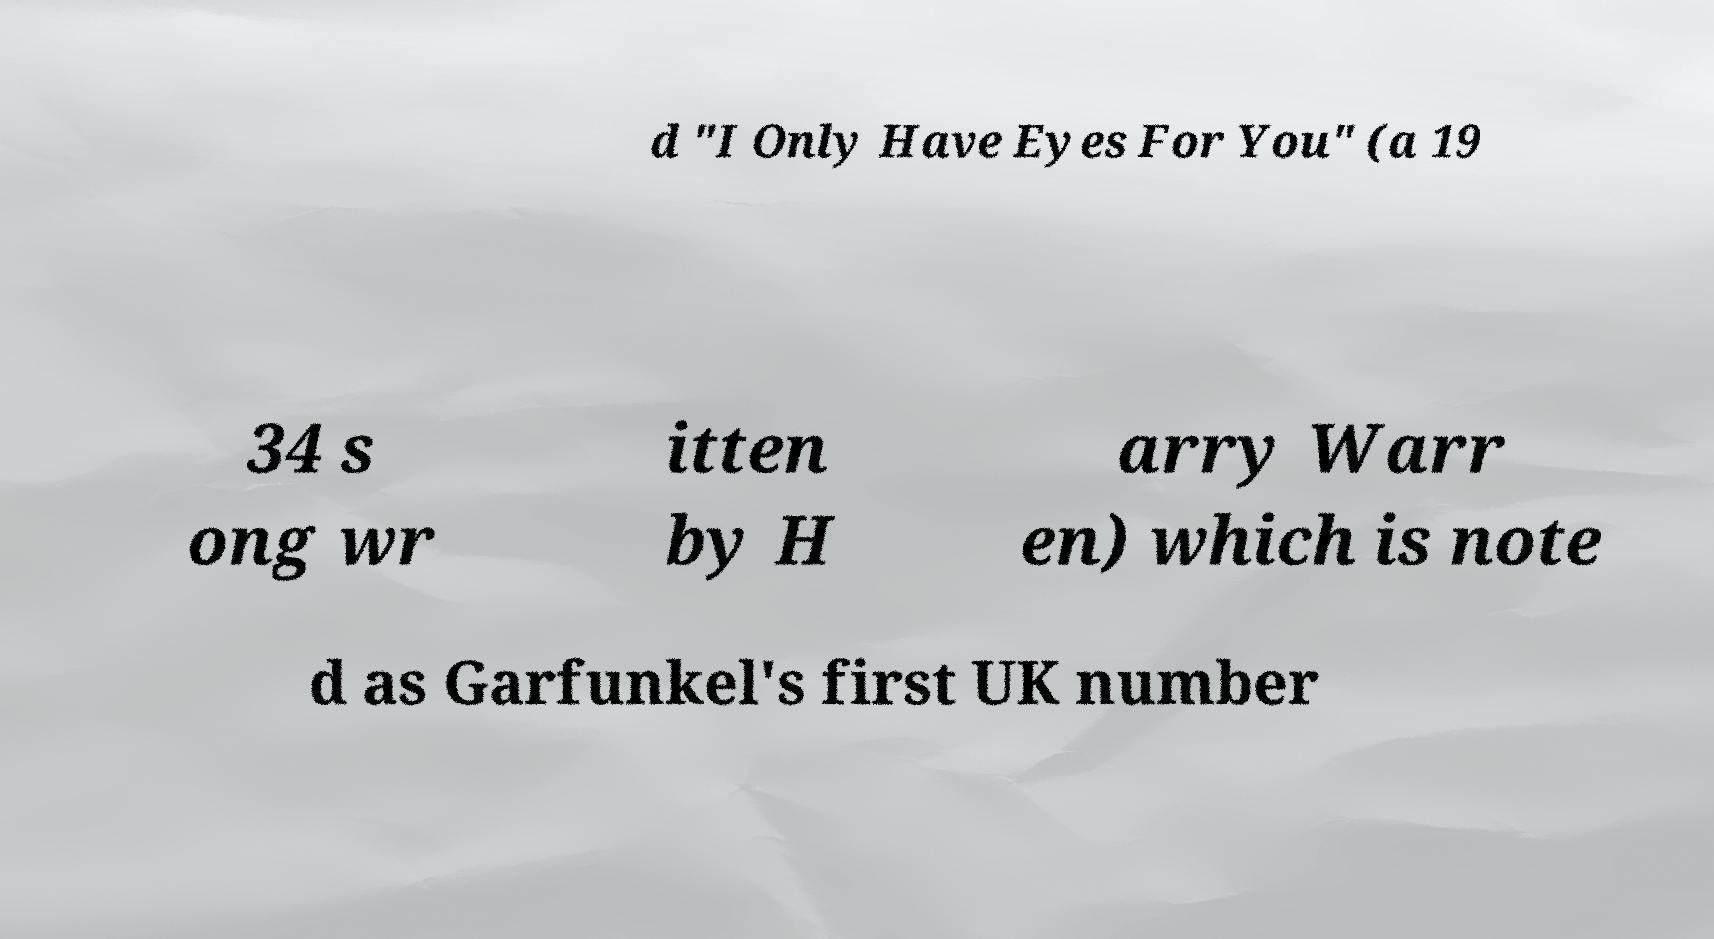For documentation purposes, I need the text within this image transcribed. Could you provide that? d "I Only Have Eyes For You" (a 19 34 s ong wr itten by H arry Warr en) which is note d as Garfunkel's first UK number 